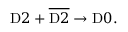Convert formula to latex. <formula><loc_0><loc_0><loc_500><loc_500>D 2 + \overline { D 2 } \rightarrow D 0 .</formula> 